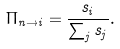<formula> <loc_0><loc_0><loc_500><loc_500>\Pi _ { n \to i } = \frac { s _ { i } } { \sum _ { j } s _ { j } } .</formula> 